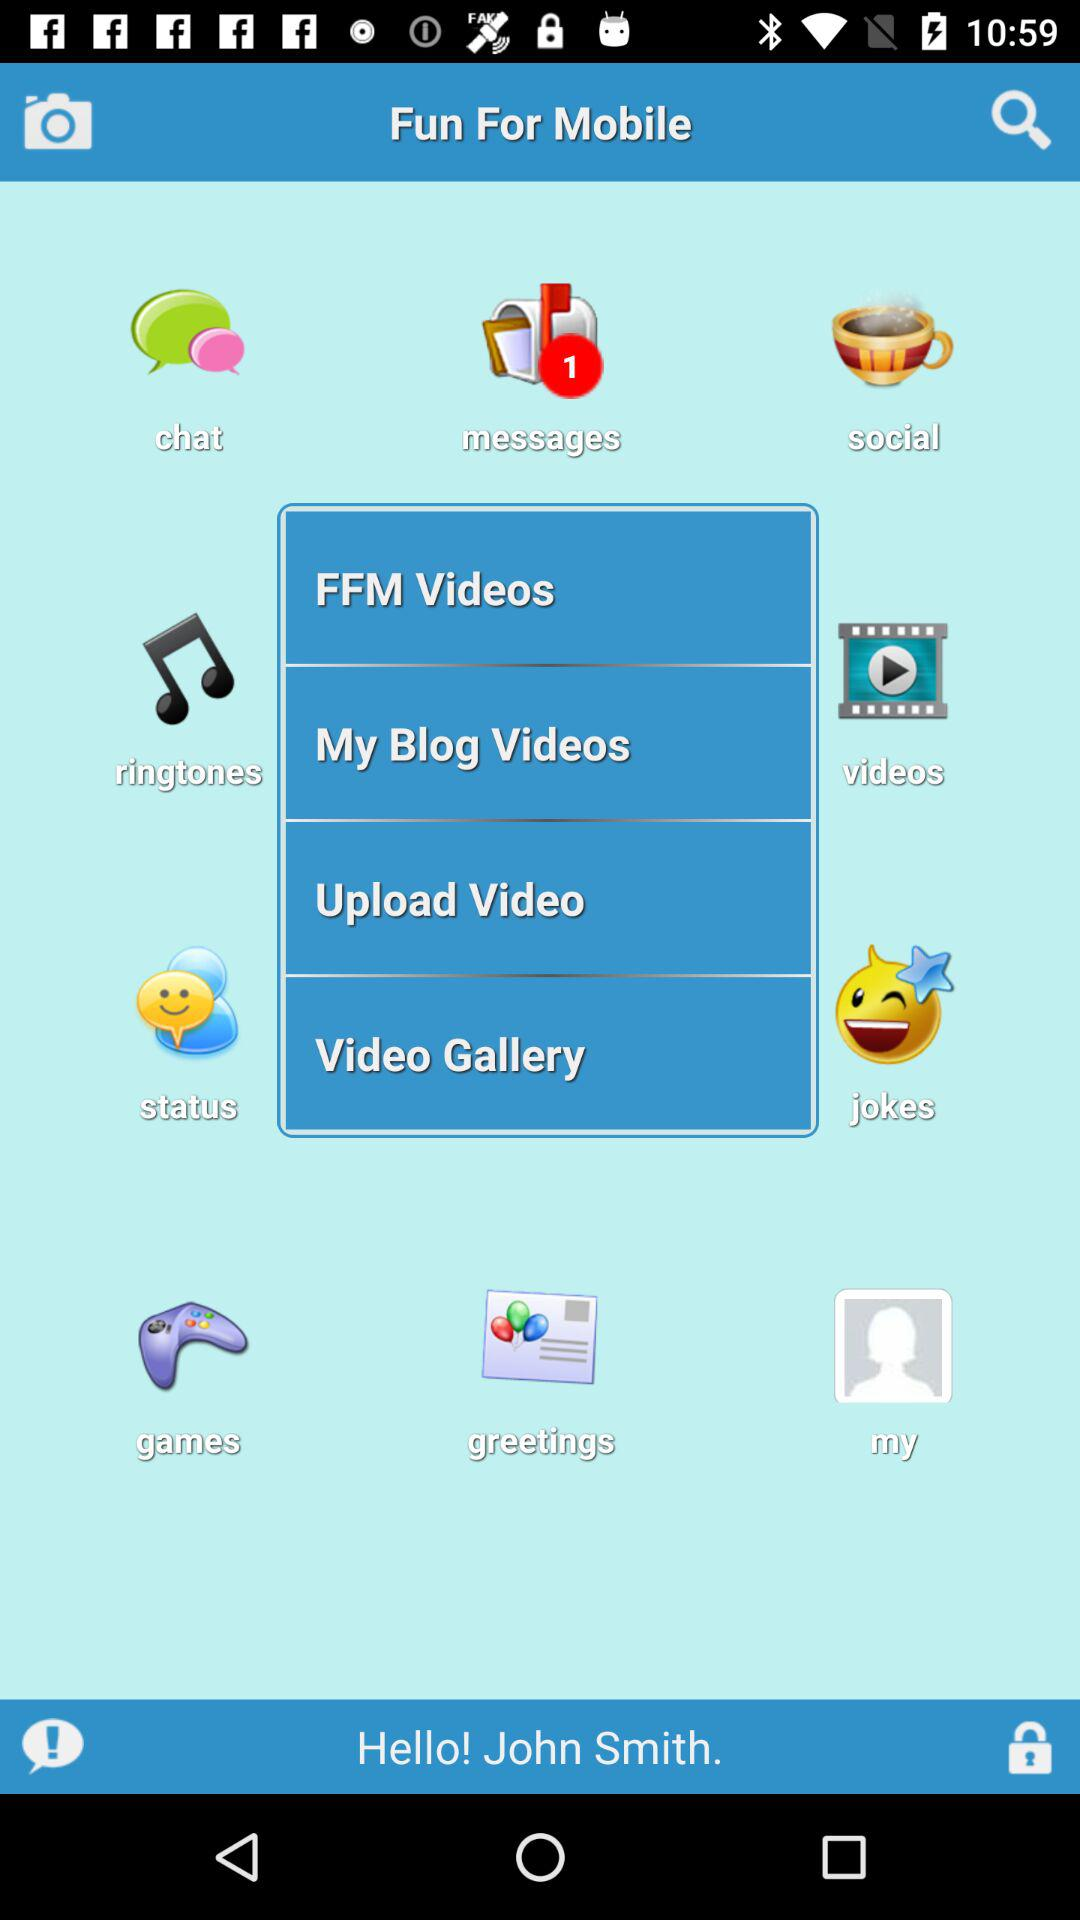What is the user's name? The user's name is John Smith. 